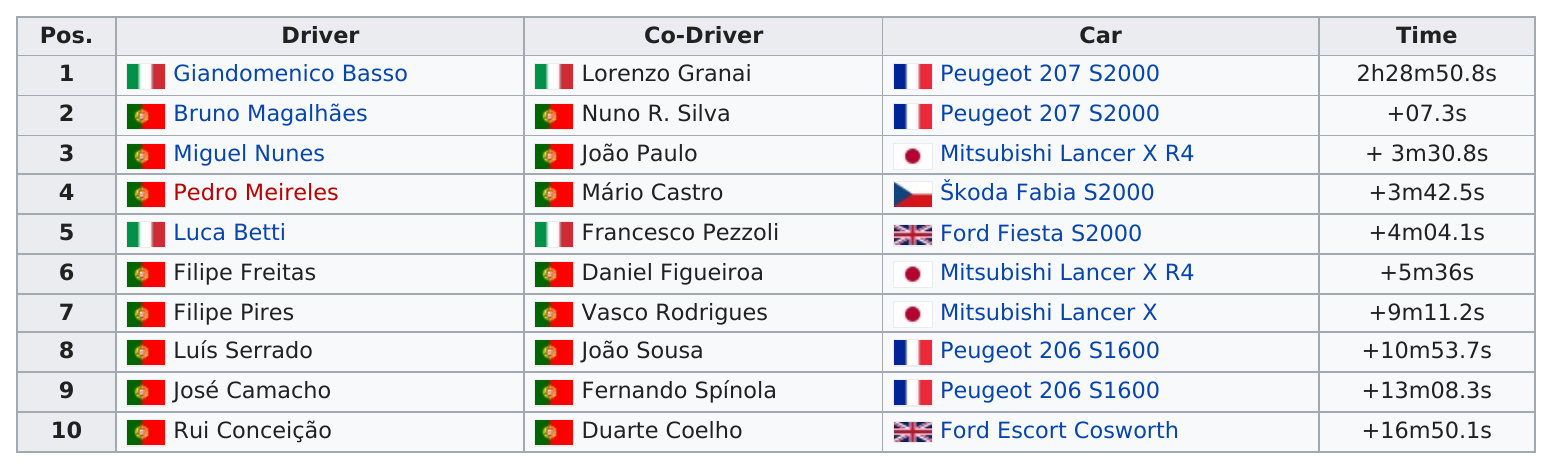Outline some significant characteristics in this image. It is known that José Camacho was the driver of the car that Luis Serrado drove. Giandomenico Basso completed the 2013 Rali Vinho da Madeira in a time of 2 hours and 28 minutes and 50.8 seconds. Lorenzo Granai was the co-driver of the first-place driver in the competition. Luca Betti finished 4 minutes and 4.1 seconds behind Giandomenico Basso in the race. The top finisher from Japan was Miguel Nunes. 